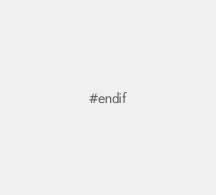Convert code to text. <code><loc_0><loc_0><loc_500><loc_500><_Cuda_>#endif
</code> 